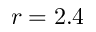Convert formula to latex. <formula><loc_0><loc_0><loc_500><loc_500>r = 2 . 4</formula> 